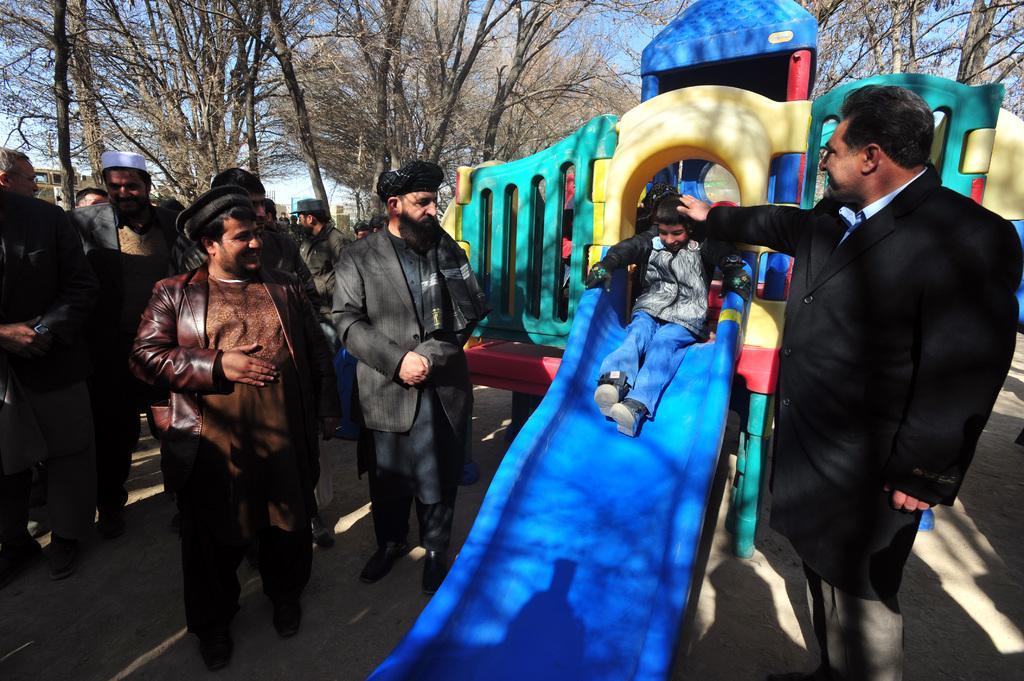How would you summarize this image in a sentence or two? This is the picture of a place where we have a kid on the slide board and around there are some other people and some trees and plants. 